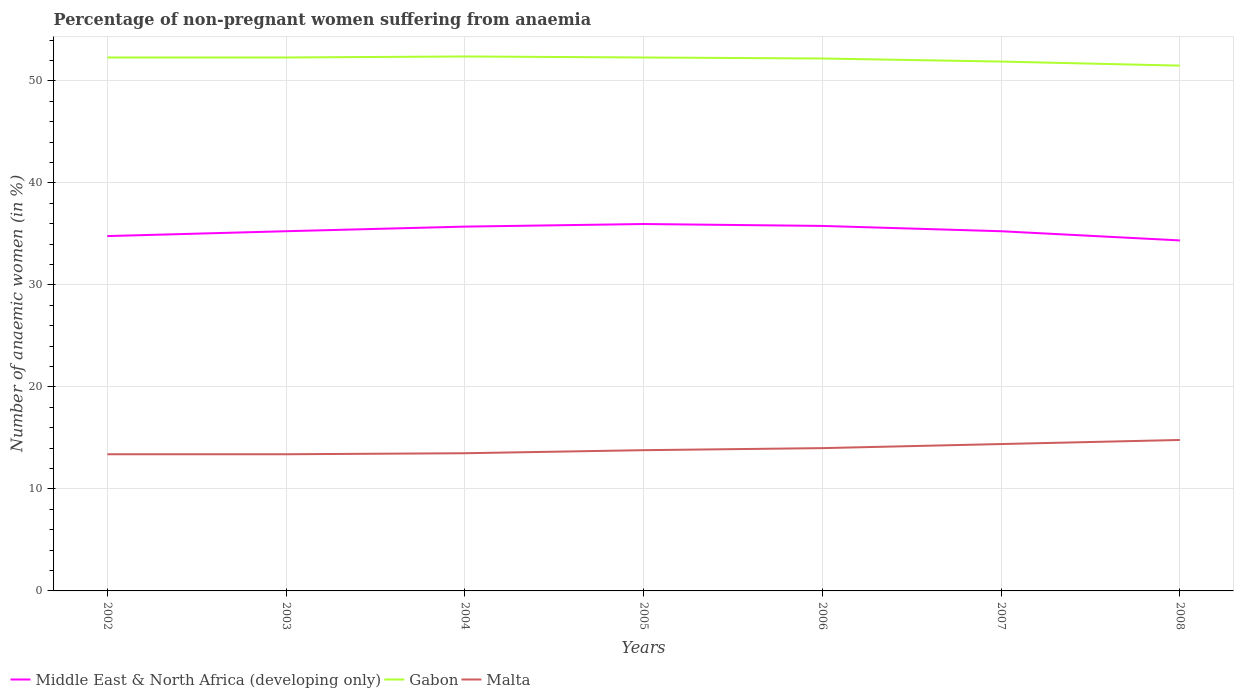How many different coloured lines are there?
Offer a very short reply. 3. Across all years, what is the maximum percentage of non-pregnant women suffering from anaemia in Gabon?
Ensure brevity in your answer.  51.5. In which year was the percentage of non-pregnant women suffering from anaemia in Gabon maximum?
Give a very brief answer. 2008. What is the total percentage of non-pregnant women suffering from anaemia in Malta in the graph?
Give a very brief answer. -0.6. What is the difference between the highest and the second highest percentage of non-pregnant women suffering from anaemia in Middle East & North Africa (developing only)?
Offer a terse response. 1.61. What is the difference between the highest and the lowest percentage of non-pregnant women suffering from anaemia in Gabon?
Give a very brief answer. 5. How many lines are there?
Keep it short and to the point. 3. What is the difference between two consecutive major ticks on the Y-axis?
Ensure brevity in your answer.  10. Where does the legend appear in the graph?
Your answer should be very brief. Bottom left. How many legend labels are there?
Give a very brief answer. 3. What is the title of the graph?
Your answer should be very brief. Percentage of non-pregnant women suffering from anaemia. What is the label or title of the Y-axis?
Make the answer very short. Number of anaemic women (in %). What is the Number of anaemic women (in %) of Middle East & North Africa (developing only) in 2002?
Make the answer very short. 34.79. What is the Number of anaemic women (in %) in Gabon in 2002?
Your answer should be very brief. 52.3. What is the Number of anaemic women (in %) in Middle East & North Africa (developing only) in 2003?
Ensure brevity in your answer.  35.27. What is the Number of anaemic women (in %) in Gabon in 2003?
Provide a succinct answer. 52.3. What is the Number of anaemic women (in %) of Malta in 2003?
Your answer should be very brief. 13.4. What is the Number of anaemic women (in %) in Middle East & North Africa (developing only) in 2004?
Keep it short and to the point. 35.72. What is the Number of anaemic women (in %) in Gabon in 2004?
Your response must be concise. 52.4. What is the Number of anaemic women (in %) in Malta in 2004?
Your answer should be compact. 13.5. What is the Number of anaemic women (in %) in Middle East & North Africa (developing only) in 2005?
Make the answer very short. 35.97. What is the Number of anaemic women (in %) of Gabon in 2005?
Provide a succinct answer. 52.3. What is the Number of anaemic women (in %) in Malta in 2005?
Offer a terse response. 13.8. What is the Number of anaemic women (in %) of Middle East & North Africa (developing only) in 2006?
Provide a short and direct response. 35.79. What is the Number of anaemic women (in %) of Gabon in 2006?
Ensure brevity in your answer.  52.2. What is the Number of anaemic women (in %) in Middle East & North Africa (developing only) in 2007?
Offer a terse response. 35.26. What is the Number of anaemic women (in %) of Gabon in 2007?
Your response must be concise. 51.9. What is the Number of anaemic women (in %) in Middle East & North Africa (developing only) in 2008?
Provide a succinct answer. 34.36. What is the Number of anaemic women (in %) in Gabon in 2008?
Offer a very short reply. 51.5. What is the Number of anaemic women (in %) of Malta in 2008?
Make the answer very short. 14.8. Across all years, what is the maximum Number of anaemic women (in %) in Middle East & North Africa (developing only)?
Your answer should be compact. 35.97. Across all years, what is the maximum Number of anaemic women (in %) in Gabon?
Offer a very short reply. 52.4. Across all years, what is the minimum Number of anaemic women (in %) of Middle East & North Africa (developing only)?
Make the answer very short. 34.36. Across all years, what is the minimum Number of anaemic women (in %) of Gabon?
Provide a succinct answer. 51.5. What is the total Number of anaemic women (in %) of Middle East & North Africa (developing only) in the graph?
Offer a terse response. 247.16. What is the total Number of anaemic women (in %) of Gabon in the graph?
Keep it short and to the point. 364.9. What is the total Number of anaemic women (in %) in Malta in the graph?
Make the answer very short. 97.3. What is the difference between the Number of anaemic women (in %) in Middle East & North Africa (developing only) in 2002 and that in 2003?
Make the answer very short. -0.48. What is the difference between the Number of anaemic women (in %) of Gabon in 2002 and that in 2003?
Keep it short and to the point. 0. What is the difference between the Number of anaemic women (in %) of Malta in 2002 and that in 2003?
Offer a terse response. 0. What is the difference between the Number of anaemic women (in %) of Middle East & North Africa (developing only) in 2002 and that in 2004?
Your response must be concise. -0.93. What is the difference between the Number of anaemic women (in %) of Gabon in 2002 and that in 2004?
Ensure brevity in your answer.  -0.1. What is the difference between the Number of anaemic women (in %) in Malta in 2002 and that in 2004?
Provide a short and direct response. -0.1. What is the difference between the Number of anaemic women (in %) of Middle East & North Africa (developing only) in 2002 and that in 2005?
Provide a short and direct response. -1.18. What is the difference between the Number of anaemic women (in %) in Gabon in 2002 and that in 2005?
Provide a succinct answer. 0. What is the difference between the Number of anaemic women (in %) of Middle East & North Africa (developing only) in 2002 and that in 2006?
Provide a short and direct response. -1. What is the difference between the Number of anaemic women (in %) of Gabon in 2002 and that in 2006?
Your response must be concise. 0.1. What is the difference between the Number of anaemic women (in %) in Malta in 2002 and that in 2006?
Make the answer very short. -0.6. What is the difference between the Number of anaemic women (in %) of Middle East & North Africa (developing only) in 2002 and that in 2007?
Ensure brevity in your answer.  -0.47. What is the difference between the Number of anaemic women (in %) in Malta in 2002 and that in 2007?
Offer a terse response. -1. What is the difference between the Number of anaemic women (in %) in Middle East & North Africa (developing only) in 2002 and that in 2008?
Make the answer very short. 0.43. What is the difference between the Number of anaemic women (in %) of Middle East & North Africa (developing only) in 2003 and that in 2004?
Offer a very short reply. -0.45. What is the difference between the Number of anaemic women (in %) in Gabon in 2003 and that in 2004?
Provide a succinct answer. -0.1. What is the difference between the Number of anaemic women (in %) in Middle East & North Africa (developing only) in 2003 and that in 2005?
Your response must be concise. -0.71. What is the difference between the Number of anaemic women (in %) of Gabon in 2003 and that in 2005?
Provide a short and direct response. 0. What is the difference between the Number of anaemic women (in %) of Middle East & North Africa (developing only) in 2003 and that in 2006?
Your answer should be compact. -0.52. What is the difference between the Number of anaemic women (in %) in Gabon in 2003 and that in 2006?
Give a very brief answer. 0.1. What is the difference between the Number of anaemic women (in %) of Middle East & North Africa (developing only) in 2003 and that in 2007?
Keep it short and to the point. 0. What is the difference between the Number of anaemic women (in %) in Gabon in 2003 and that in 2007?
Make the answer very short. 0.4. What is the difference between the Number of anaemic women (in %) in Middle East & North Africa (developing only) in 2003 and that in 2008?
Offer a very short reply. 0.9. What is the difference between the Number of anaemic women (in %) of Middle East & North Africa (developing only) in 2004 and that in 2005?
Give a very brief answer. -0.25. What is the difference between the Number of anaemic women (in %) of Malta in 2004 and that in 2005?
Make the answer very short. -0.3. What is the difference between the Number of anaemic women (in %) in Middle East & North Africa (developing only) in 2004 and that in 2006?
Offer a very short reply. -0.07. What is the difference between the Number of anaemic women (in %) of Middle East & North Africa (developing only) in 2004 and that in 2007?
Provide a short and direct response. 0.45. What is the difference between the Number of anaemic women (in %) in Middle East & North Africa (developing only) in 2004 and that in 2008?
Offer a terse response. 1.36. What is the difference between the Number of anaemic women (in %) of Gabon in 2004 and that in 2008?
Your answer should be compact. 0.9. What is the difference between the Number of anaemic women (in %) in Middle East & North Africa (developing only) in 2005 and that in 2006?
Your answer should be very brief. 0.19. What is the difference between the Number of anaemic women (in %) of Gabon in 2005 and that in 2006?
Your answer should be very brief. 0.1. What is the difference between the Number of anaemic women (in %) of Malta in 2005 and that in 2006?
Make the answer very short. -0.2. What is the difference between the Number of anaemic women (in %) in Middle East & North Africa (developing only) in 2005 and that in 2007?
Provide a succinct answer. 0.71. What is the difference between the Number of anaemic women (in %) of Gabon in 2005 and that in 2007?
Ensure brevity in your answer.  0.4. What is the difference between the Number of anaemic women (in %) in Middle East & North Africa (developing only) in 2005 and that in 2008?
Provide a succinct answer. 1.61. What is the difference between the Number of anaemic women (in %) of Malta in 2005 and that in 2008?
Your answer should be compact. -1. What is the difference between the Number of anaemic women (in %) of Middle East & North Africa (developing only) in 2006 and that in 2007?
Give a very brief answer. 0.52. What is the difference between the Number of anaemic women (in %) of Gabon in 2006 and that in 2007?
Ensure brevity in your answer.  0.3. What is the difference between the Number of anaemic women (in %) of Malta in 2006 and that in 2007?
Offer a very short reply. -0.4. What is the difference between the Number of anaemic women (in %) of Middle East & North Africa (developing only) in 2006 and that in 2008?
Provide a short and direct response. 1.42. What is the difference between the Number of anaemic women (in %) of Gabon in 2006 and that in 2008?
Your answer should be compact. 0.7. What is the difference between the Number of anaemic women (in %) of Malta in 2006 and that in 2008?
Your response must be concise. -0.8. What is the difference between the Number of anaemic women (in %) in Middle East & North Africa (developing only) in 2007 and that in 2008?
Offer a terse response. 0.9. What is the difference between the Number of anaemic women (in %) in Gabon in 2007 and that in 2008?
Give a very brief answer. 0.4. What is the difference between the Number of anaemic women (in %) of Middle East & North Africa (developing only) in 2002 and the Number of anaemic women (in %) of Gabon in 2003?
Offer a terse response. -17.51. What is the difference between the Number of anaemic women (in %) of Middle East & North Africa (developing only) in 2002 and the Number of anaemic women (in %) of Malta in 2003?
Ensure brevity in your answer.  21.39. What is the difference between the Number of anaemic women (in %) in Gabon in 2002 and the Number of anaemic women (in %) in Malta in 2003?
Ensure brevity in your answer.  38.9. What is the difference between the Number of anaemic women (in %) of Middle East & North Africa (developing only) in 2002 and the Number of anaemic women (in %) of Gabon in 2004?
Ensure brevity in your answer.  -17.61. What is the difference between the Number of anaemic women (in %) of Middle East & North Africa (developing only) in 2002 and the Number of anaemic women (in %) of Malta in 2004?
Provide a succinct answer. 21.29. What is the difference between the Number of anaemic women (in %) in Gabon in 2002 and the Number of anaemic women (in %) in Malta in 2004?
Make the answer very short. 38.8. What is the difference between the Number of anaemic women (in %) of Middle East & North Africa (developing only) in 2002 and the Number of anaemic women (in %) of Gabon in 2005?
Your answer should be very brief. -17.51. What is the difference between the Number of anaemic women (in %) in Middle East & North Africa (developing only) in 2002 and the Number of anaemic women (in %) in Malta in 2005?
Give a very brief answer. 20.99. What is the difference between the Number of anaemic women (in %) of Gabon in 2002 and the Number of anaemic women (in %) of Malta in 2005?
Your answer should be very brief. 38.5. What is the difference between the Number of anaemic women (in %) in Middle East & North Africa (developing only) in 2002 and the Number of anaemic women (in %) in Gabon in 2006?
Your answer should be very brief. -17.41. What is the difference between the Number of anaemic women (in %) of Middle East & North Africa (developing only) in 2002 and the Number of anaemic women (in %) of Malta in 2006?
Give a very brief answer. 20.79. What is the difference between the Number of anaemic women (in %) in Gabon in 2002 and the Number of anaemic women (in %) in Malta in 2006?
Give a very brief answer. 38.3. What is the difference between the Number of anaemic women (in %) of Middle East & North Africa (developing only) in 2002 and the Number of anaemic women (in %) of Gabon in 2007?
Provide a succinct answer. -17.11. What is the difference between the Number of anaemic women (in %) of Middle East & North Africa (developing only) in 2002 and the Number of anaemic women (in %) of Malta in 2007?
Offer a very short reply. 20.39. What is the difference between the Number of anaemic women (in %) in Gabon in 2002 and the Number of anaemic women (in %) in Malta in 2007?
Provide a succinct answer. 37.9. What is the difference between the Number of anaemic women (in %) in Middle East & North Africa (developing only) in 2002 and the Number of anaemic women (in %) in Gabon in 2008?
Your answer should be compact. -16.71. What is the difference between the Number of anaemic women (in %) in Middle East & North Africa (developing only) in 2002 and the Number of anaemic women (in %) in Malta in 2008?
Make the answer very short. 19.99. What is the difference between the Number of anaemic women (in %) in Gabon in 2002 and the Number of anaemic women (in %) in Malta in 2008?
Your answer should be compact. 37.5. What is the difference between the Number of anaemic women (in %) in Middle East & North Africa (developing only) in 2003 and the Number of anaemic women (in %) in Gabon in 2004?
Offer a very short reply. -17.13. What is the difference between the Number of anaemic women (in %) of Middle East & North Africa (developing only) in 2003 and the Number of anaemic women (in %) of Malta in 2004?
Keep it short and to the point. 21.77. What is the difference between the Number of anaemic women (in %) of Gabon in 2003 and the Number of anaemic women (in %) of Malta in 2004?
Offer a very short reply. 38.8. What is the difference between the Number of anaemic women (in %) of Middle East & North Africa (developing only) in 2003 and the Number of anaemic women (in %) of Gabon in 2005?
Offer a terse response. -17.03. What is the difference between the Number of anaemic women (in %) in Middle East & North Africa (developing only) in 2003 and the Number of anaemic women (in %) in Malta in 2005?
Provide a short and direct response. 21.47. What is the difference between the Number of anaemic women (in %) in Gabon in 2003 and the Number of anaemic women (in %) in Malta in 2005?
Provide a short and direct response. 38.5. What is the difference between the Number of anaemic women (in %) of Middle East & North Africa (developing only) in 2003 and the Number of anaemic women (in %) of Gabon in 2006?
Make the answer very short. -16.93. What is the difference between the Number of anaemic women (in %) of Middle East & North Africa (developing only) in 2003 and the Number of anaemic women (in %) of Malta in 2006?
Provide a succinct answer. 21.27. What is the difference between the Number of anaemic women (in %) in Gabon in 2003 and the Number of anaemic women (in %) in Malta in 2006?
Your answer should be compact. 38.3. What is the difference between the Number of anaemic women (in %) in Middle East & North Africa (developing only) in 2003 and the Number of anaemic women (in %) in Gabon in 2007?
Make the answer very short. -16.63. What is the difference between the Number of anaemic women (in %) in Middle East & North Africa (developing only) in 2003 and the Number of anaemic women (in %) in Malta in 2007?
Your answer should be very brief. 20.87. What is the difference between the Number of anaemic women (in %) of Gabon in 2003 and the Number of anaemic women (in %) of Malta in 2007?
Provide a succinct answer. 37.9. What is the difference between the Number of anaemic women (in %) in Middle East & North Africa (developing only) in 2003 and the Number of anaemic women (in %) in Gabon in 2008?
Your answer should be very brief. -16.23. What is the difference between the Number of anaemic women (in %) in Middle East & North Africa (developing only) in 2003 and the Number of anaemic women (in %) in Malta in 2008?
Make the answer very short. 20.47. What is the difference between the Number of anaemic women (in %) of Gabon in 2003 and the Number of anaemic women (in %) of Malta in 2008?
Offer a very short reply. 37.5. What is the difference between the Number of anaemic women (in %) of Middle East & North Africa (developing only) in 2004 and the Number of anaemic women (in %) of Gabon in 2005?
Your answer should be compact. -16.58. What is the difference between the Number of anaemic women (in %) in Middle East & North Africa (developing only) in 2004 and the Number of anaemic women (in %) in Malta in 2005?
Provide a short and direct response. 21.92. What is the difference between the Number of anaemic women (in %) in Gabon in 2004 and the Number of anaemic women (in %) in Malta in 2005?
Offer a very short reply. 38.6. What is the difference between the Number of anaemic women (in %) of Middle East & North Africa (developing only) in 2004 and the Number of anaemic women (in %) of Gabon in 2006?
Keep it short and to the point. -16.48. What is the difference between the Number of anaemic women (in %) of Middle East & North Africa (developing only) in 2004 and the Number of anaemic women (in %) of Malta in 2006?
Make the answer very short. 21.72. What is the difference between the Number of anaemic women (in %) in Gabon in 2004 and the Number of anaemic women (in %) in Malta in 2006?
Offer a terse response. 38.4. What is the difference between the Number of anaemic women (in %) in Middle East & North Africa (developing only) in 2004 and the Number of anaemic women (in %) in Gabon in 2007?
Your answer should be very brief. -16.18. What is the difference between the Number of anaemic women (in %) of Middle East & North Africa (developing only) in 2004 and the Number of anaemic women (in %) of Malta in 2007?
Ensure brevity in your answer.  21.32. What is the difference between the Number of anaemic women (in %) of Gabon in 2004 and the Number of anaemic women (in %) of Malta in 2007?
Offer a very short reply. 38. What is the difference between the Number of anaemic women (in %) of Middle East & North Africa (developing only) in 2004 and the Number of anaemic women (in %) of Gabon in 2008?
Give a very brief answer. -15.78. What is the difference between the Number of anaemic women (in %) in Middle East & North Africa (developing only) in 2004 and the Number of anaemic women (in %) in Malta in 2008?
Give a very brief answer. 20.92. What is the difference between the Number of anaemic women (in %) in Gabon in 2004 and the Number of anaemic women (in %) in Malta in 2008?
Offer a terse response. 37.6. What is the difference between the Number of anaemic women (in %) of Middle East & North Africa (developing only) in 2005 and the Number of anaemic women (in %) of Gabon in 2006?
Your response must be concise. -16.23. What is the difference between the Number of anaemic women (in %) of Middle East & North Africa (developing only) in 2005 and the Number of anaemic women (in %) of Malta in 2006?
Your response must be concise. 21.97. What is the difference between the Number of anaemic women (in %) in Gabon in 2005 and the Number of anaemic women (in %) in Malta in 2006?
Your response must be concise. 38.3. What is the difference between the Number of anaemic women (in %) of Middle East & North Africa (developing only) in 2005 and the Number of anaemic women (in %) of Gabon in 2007?
Ensure brevity in your answer.  -15.93. What is the difference between the Number of anaemic women (in %) of Middle East & North Africa (developing only) in 2005 and the Number of anaemic women (in %) of Malta in 2007?
Make the answer very short. 21.57. What is the difference between the Number of anaemic women (in %) in Gabon in 2005 and the Number of anaemic women (in %) in Malta in 2007?
Keep it short and to the point. 37.9. What is the difference between the Number of anaemic women (in %) in Middle East & North Africa (developing only) in 2005 and the Number of anaemic women (in %) in Gabon in 2008?
Provide a short and direct response. -15.53. What is the difference between the Number of anaemic women (in %) in Middle East & North Africa (developing only) in 2005 and the Number of anaemic women (in %) in Malta in 2008?
Offer a terse response. 21.17. What is the difference between the Number of anaemic women (in %) in Gabon in 2005 and the Number of anaemic women (in %) in Malta in 2008?
Ensure brevity in your answer.  37.5. What is the difference between the Number of anaemic women (in %) in Middle East & North Africa (developing only) in 2006 and the Number of anaemic women (in %) in Gabon in 2007?
Ensure brevity in your answer.  -16.11. What is the difference between the Number of anaemic women (in %) of Middle East & North Africa (developing only) in 2006 and the Number of anaemic women (in %) of Malta in 2007?
Your answer should be very brief. 21.39. What is the difference between the Number of anaemic women (in %) in Gabon in 2006 and the Number of anaemic women (in %) in Malta in 2007?
Offer a very short reply. 37.8. What is the difference between the Number of anaemic women (in %) of Middle East & North Africa (developing only) in 2006 and the Number of anaemic women (in %) of Gabon in 2008?
Offer a terse response. -15.71. What is the difference between the Number of anaemic women (in %) of Middle East & North Africa (developing only) in 2006 and the Number of anaemic women (in %) of Malta in 2008?
Offer a very short reply. 20.98. What is the difference between the Number of anaemic women (in %) in Gabon in 2006 and the Number of anaemic women (in %) in Malta in 2008?
Provide a short and direct response. 37.4. What is the difference between the Number of anaemic women (in %) of Middle East & North Africa (developing only) in 2007 and the Number of anaemic women (in %) of Gabon in 2008?
Ensure brevity in your answer.  -16.24. What is the difference between the Number of anaemic women (in %) of Middle East & North Africa (developing only) in 2007 and the Number of anaemic women (in %) of Malta in 2008?
Keep it short and to the point. 20.46. What is the difference between the Number of anaemic women (in %) of Gabon in 2007 and the Number of anaemic women (in %) of Malta in 2008?
Offer a very short reply. 37.1. What is the average Number of anaemic women (in %) in Middle East & North Africa (developing only) per year?
Provide a short and direct response. 35.31. What is the average Number of anaemic women (in %) of Gabon per year?
Keep it short and to the point. 52.13. In the year 2002, what is the difference between the Number of anaemic women (in %) of Middle East & North Africa (developing only) and Number of anaemic women (in %) of Gabon?
Ensure brevity in your answer.  -17.51. In the year 2002, what is the difference between the Number of anaemic women (in %) in Middle East & North Africa (developing only) and Number of anaemic women (in %) in Malta?
Make the answer very short. 21.39. In the year 2002, what is the difference between the Number of anaemic women (in %) of Gabon and Number of anaemic women (in %) of Malta?
Your answer should be compact. 38.9. In the year 2003, what is the difference between the Number of anaemic women (in %) in Middle East & North Africa (developing only) and Number of anaemic women (in %) in Gabon?
Make the answer very short. -17.03. In the year 2003, what is the difference between the Number of anaemic women (in %) of Middle East & North Africa (developing only) and Number of anaemic women (in %) of Malta?
Your answer should be compact. 21.87. In the year 2003, what is the difference between the Number of anaemic women (in %) of Gabon and Number of anaemic women (in %) of Malta?
Provide a short and direct response. 38.9. In the year 2004, what is the difference between the Number of anaemic women (in %) in Middle East & North Africa (developing only) and Number of anaemic women (in %) in Gabon?
Your response must be concise. -16.68. In the year 2004, what is the difference between the Number of anaemic women (in %) of Middle East & North Africa (developing only) and Number of anaemic women (in %) of Malta?
Keep it short and to the point. 22.22. In the year 2004, what is the difference between the Number of anaemic women (in %) of Gabon and Number of anaemic women (in %) of Malta?
Provide a short and direct response. 38.9. In the year 2005, what is the difference between the Number of anaemic women (in %) of Middle East & North Africa (developing only) and Number of anaemic women (in %) of Gabon?
Your answer should be compact. -16.33. In the year 2005, what is the difference between the Number of anaemic women (in %) in Middle East & North Africa (developing only) and Number of anaemic women (in %) in Malta?
Your answer should be very brief. 22.17. In the year 2005, what is the difference between the Number of anaemic women (in %) of Gabon and Number of anaemic women (in %) of Malta?
Your answer should be compact. 38.5. In the year 2006, what is the difference between the Number of anaemic women (in %) of Middle East & North Africa (developing only) and Number of anaemic women (in %) of Gabon?
Provide a succinct answer. -16.41. In the year 2006, what is the difference between the Number of anaemic women (in %) in Middle East & North Africa (developing only) and Number of anaemic women (in %) in Malta?
Provide a succinct answer. 21.79. In the year 2006, what is the difference between the Number of anaemic women (in %) of Gabon and Number of anaemic women (in %) of Malta?
Offer a very short reply. 38.2. In the year 2007, what is the difference between the Number of anaemic women (in %) of Middle East & North Africa (developing only) and Number of anaemic women (in %) of Gabon?
Offer a terse response. -16.64. In the year 2007, what is the difference between the Number of anaemic women (in %) in Middle East & North Africa (developing only) and Number of anaemic women (in %) in Malta?
Your answer should be compact. 20.86. In the year 2007, what is the difference between the Number of anaemic women (in %) of Gabon and Number of anaemic women (in %) of Malta?
Provide a short and direct response. 37.5. In the year 2008, what is the difference between the Number of anaemic women (in %) of Middle East & North Africa (developing only) and Number of anaemic women (in %) of Gabon?
Provide a succinct answer. -17.14. In the year 2008, what is the difference between the Number of anaemic women (in %) of Middle East & North Africa (developing only) and Number of anaemic women (in %) of Malta?
Offer a terse response. 19.56. In the year 2008, what is the difference between the Number of anaemic women (in %) of Gabon and Number of anaemic women (in %) of Malta?
Offer a terse response. 36.7. What is the ratio of the Number of anaemic women (in %) in Middle East & North Africa (developing only) in 2002 to that in 2003?
Your answer should be compact. 0.99. What is the ratio of the Number of anaemic women (in %) in Gabon in 2002 to that in 2003?
Offer a terse response. 1. What is the ratio of the Number of anaemic women (in %) of Malta in 2002 to that in 2003?
Ensure brevity in your answer.  1. What is the ratio of the Number of anaemic women (in %) in Middle East & North Africa (developing only) in 2002 to that in 2005?
Provide a short and direct response. 0.97. What is the ratio of the Number of anaemic women (in %) of Gabon in 2002 to that in 2005?
Offer a very short reply. 1. What is the ratio of the Number of anaemic women (in %) in Malta in 2002 to that in 2005?
Make the answer very short. 0.97. What is the ratio of the Number of anaemic women (in %) of Middle East & North Africa (developing only) in 2002 to that in 2006?
Your response must be concise. 0.97. What is the ratio of the Number of anaemic women (in %) of Malta in 2002 to that in 2006?
Your answer should be compact. 0.96. What is the ratio of the Number of anaemic women (in %) of Middle East & North Africa (developing only) in 2002 to that in 2007?
Give a very brief answer. 0.99. What is the ratio of the Number of anaemic women (in %) of Gabon in 2002 to that in 2007?
Offer a terse response. 1.01. What is the ratio of the Number of anaemic women (in %) in Malta in 2002 to that in 2007?
Offer a very short reply. 0.93. What is the ratio of the Number of anaemic women (in %) in Middle East & North Africa (developing only) in 2002 to that in 2008?
Offer a very short reply. 1.01. What is the ratio of the Number of anaemic women (in %) in Gabon in 2002 to that in 2008?
Offer a very short reply. 1.02. What is the ratio of the Number of anaemic women (in %) of Malta in 2002 to that in 2008?
Provide a short and direct response. 0.91. What is the ratio of the Number of anaemic women (in %) of Middle East & North Africa (developing only) in 2003 to that in 2004?
Offer a terse response. 0.99. What is the ratio of the Number of anaemic women (in %) in Gabon in 2003 to that in 2004?
Your response must be concise. 1. What is the ratio of the Number of anaemic women (in %) in Middle East & North Africa (developing only) in 2003 to that in 2005?
Offer a terse response. 0.98. What is the ratio of the Number of anaemic women (in %) of Gabon in 2003 to that in 2005?
Offer a very short reply. 1. What is the ratio of the Number of anaemic women (in %) of Malta in 2003 to that in 2005?
Provide a succinct answer. 0.97. What is the ratio of the Number of anaemic women (in %) of Middle East & North Africa (developing only) in 2003 to that in 2006?
Provide a succinct answer. 0.99. What is the ratio of the Number of anaemic women (in %) of Malta in 2003 to that in 2006?
Offer a very short reply. 0.96. What is the ratio of the Number of anaemic women (in %) of Middle East & North Africa (developing only) in 2003 to that in 2007?
Provide a succinct answer. 1. What is the ratio of the Number of anaemic women (in %) in Gabon in 2003 to that in 2007?
Give a very brief answer. 1.01. What is the ratio of the Number of anaemic women (in %) of Malta in 2003 to that in 2007?
Your answer should be compact. 0.93. What is the ratio of the Number of anaemic women (in %) of Middle East & North Africa (developing only) in 2003 to that in 2008?
Offer a very short reply. 1.03. What is the ratio of the Number of anaemic women (in %) of Gabon in 2003 to that in 2008?
Ensure brevity in your answer.  1.02. What is the ratio of the Number of anaemic women (in %) of Malta in 2003 to that in 2008?
Your response must be concise. 0.91. What is the ratio of the Number of anaemic women (in %) in Middle East & North Africa (developing only) in 2004 to that in 2005?
Provide a succinct answer. 0.99. What is the ratio of the Number of anaemic women (in %) of Gabon in 2004 to that in 2005?
Provide a short and direct response. 1. What is the ratio of the Number of anaemic women (in %) of Malta in 2004 to that in 2005?
Offer a very short reply. 0.98. What is the ratio of the Number of anaemic women (in %) in Middle East & North Africa (developing only) in 2004 to that in 2006?
Your answer should be very brief. 1. What is the ratio of the Number of anaemic women (in %) in Malta in 2004 to that in 2006?
Your answer should be very brief. 0.96. What is the ratio of the Number of anaemic women (in %) of Middle East & North Africa (developing only) in 2004 to that in 2007?
Make the answer very short. 1.01. What is the ratio of the Number of anaemic women (in %) in Gabon in 2004 to that in 2007?
Keep it short and to the point. 1.01. What is the ratio of the Number of anaemic women (in %) in Middle East & North Africa (developing only) in 2004 to that in 2008?
Your response must be concise. 1.04. What is the ratio of the Number of anaemic women (in %) of Gabon in 2004 to that in 2008?
Your answer should be very brief. 1.02. What is the ratio of the Number of anaemic women (in %) of Malta in 2004 to that in 2008?
Ensure brevity in your answer.  0.91. What is the ratio of the Number of anaemic women (in %) of Malta in 2005 to that in 2006?
Give a very brief answer. 0.99. What is the ratio of the Number of anaemic women (in %) of Middle East & North Africa (developing only) in 2005 to that in 2007?
Offer a terse response. 1.02. What is the ratio of the Number of anaemic women (in %) of Gabon in 2005 to that in 2007?
Provide a succinct answer. 1.01. What is the ratio of the Number of anaemic women (in %) of Malta in 2005 to that in 2007?
Keep it short and to the point. 0.96. What is the ratio of the Number of anaemic women (in %) of Middle East & North Africa (developing only) in 2005 to that in 2008?
Offer a terse response. 1.05. What is the ratio of the Number of anaemic women (in %) of Gabon in 2005 to that in 2008?
Provide a succinct answer. 1.02. What is the ratio of the Number of anaemic women (in %) of Malta in 2005 to that in 2008?
Provide a short and direct response. 0.93. What is the ratio of the Number of anaemic women (in %) in Middle East & North Africa (developing only) in 2006 to that in 2007?
Keep it short and to the point. 1.01. What is the ratio of the Number of anaemic women (in %) of Gabon in 2006 to that in 2007?
Your answer should be very brief. 1.01. What is the ratio of the Number of anaemic women (in %) of Malta in 2006 to that in 2007?
Your answer should be very brief. 0.97. What is the ratio of the Number of anaemic women (in %) of Middle East & North Africa (developing only) in 2006 to that in 2008?
Ensure brevity in your answer.  1.04. What is the ratio of the Number of anaemic women (in %) in Gabon in 2006 to that in 2008?
Give a very brief answer. 1.01. What is the ratio of the Number of anaemic women (in %) in Malta in 2006 to that in 2008?
Make the answer very short. 0.95. What is the ratio of the Number of anaemic women (in %) of Middle East & North Africa (developing only) in 2007 to that in 2008?
Offer a terse response. 1.03. What is the ratio of the Number of anaemic women (in %) of Malta in 2007 to that in 2008?
Keep it short and to the point. 0.97. What is the difference between the highest and the second highest Number of anaemic women (in %) of Middle East & North Africa (developing only)?
Make the answer very short. 0.19. What is the difference between the highest and the second highest Number of anaemic women (in %) in Gabon?
Give a very brief answer. 0.1. What is the difference between the highest and the lowest Number of anaemic women (in %) of Middle East & North Africa (developing only)?
Your response must be concise. 1.61. What is the difference between the highest and the lowest Number of anaemic women (in %) of Gabon?
Give a very brief answer. 0.9. What is the difference between the highest and the lowest Number of anaemic women (in %) in Malta?
Your answer should be compact. 1.4. 